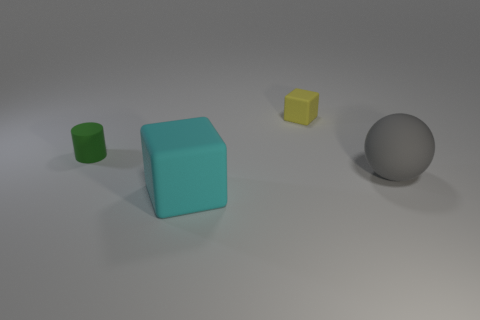Can you tell the relative sizes of these objects? Based on the image, the largest object is the turquoise cube, followed by the gray sphere. The green cylinder is smaller in size, and the smallest object is the yellow cube. The precise sizing can, however, only be guessed without a reference. 